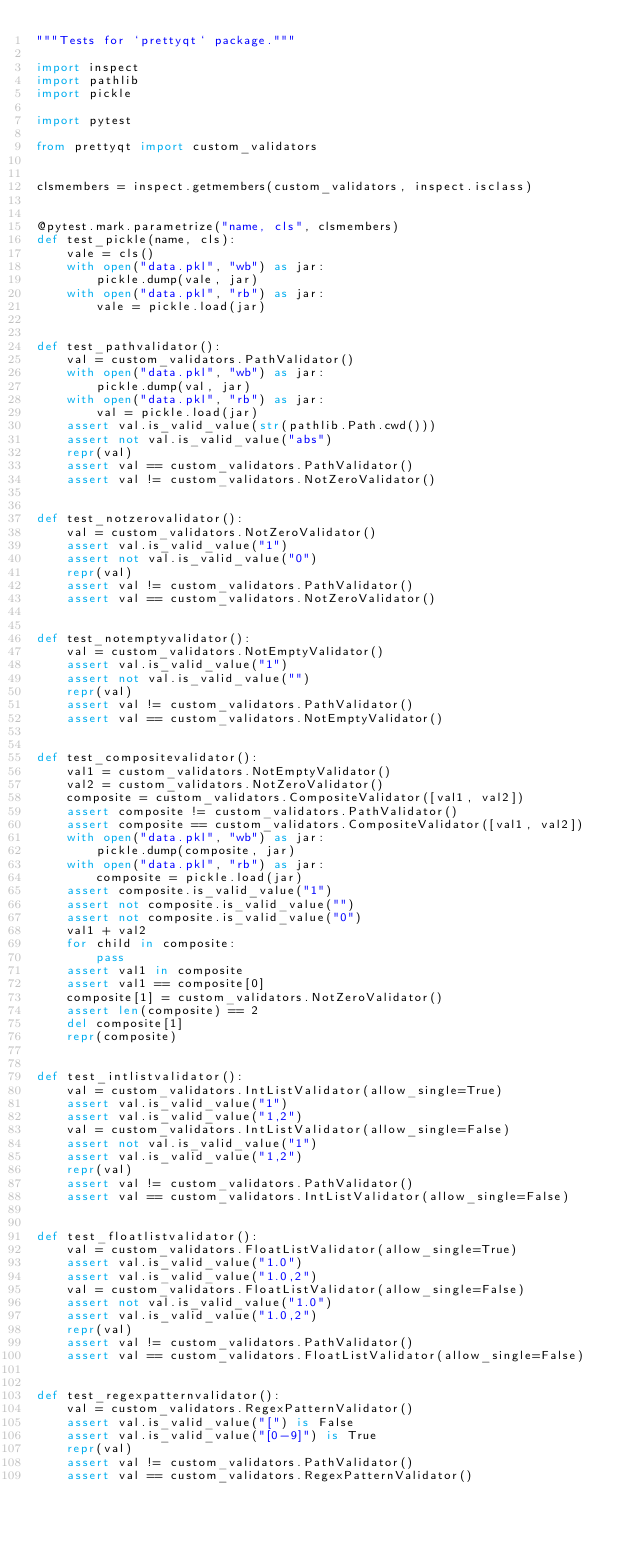<code> <loc_0><loc_0><loc_500><loc_500><_Python_>"""Tests for `prettyqt` package."""

import inspect
import pathlib
import pickle

import pytest

from prettyqt import custom_validators


clsmembers = inspect.getmembers(custom_validators, inspect.isclass)


@pytest.mark.parametrize("name, cls", clsmembers)
def test_pickle(name, cls):
    vale = cls()
    with open("data.pkl", "wb") as jar:
        pickle.dump(vale, jar)
    with open("data.pkl", "rb") as jar:
        vale = pickle.load(jar)


def test_pathvalidator():
    val = custom_validators.PathValidator()
    with open("data.pkl", "wb") as jar:
        pickle.dump(val, jar)
    with open("data.pkl", "rb") as jar:
        val = pickle.load(jar)
    assert val.is_valid_value(str(pathlib.Path.cwd()))
    assert not val.is_valid_value("abs")
    repr(val)
    assert val == custom_validators.PathValidator()
    assert val != custom_validators.NotZeroValidator()


def test_notzerovalidator():
    val = custom_validators.NotZeroValidator()
    assert val.is_valid_value("1")
    assert not val.is_valid_value("0")
    repr(val)
    assert val != custom_validators.PathValidator()
    assert val == custom_validators.NotZeroValidator()


def test_notemptyvalidator():
    val = custom_validators.NotEmptyValidator()
    assert val.is_valid_value("1")
    assert not val.is_valid_value("")
    repr(val)
    assert val != custom_validators.PathValidator()
    assert val == custom_validators.NotEmptyValidator()


def test_compositevalidator():
    val1 = custom_validators.NotEmptyValidator()
    val2 = custom_validators.NotZeroValidator()
    composite = custom_validators.CompositeValidator([val1, val2])
    assert composite != custom_validators.PathValidator()
    assert composite == custom_validators.CompositeValidator([val1, val2])
    with open("data.pkl", "wb") as jar:
        pickle.dump(composite, jar)
    with open("data.pkl", "rb") as jar:
        composite = pickle.load(jar)
    assert composite.is_valid_value("1")
    assert not composite.is_valid_value("")
    assert not composite.is_valid_value("0")
    val1 + val2
    for child in composite:
        pass
    assert val1 in composite
    assert val1 == composite[0]
    composite[1] = custom_validators.NotZeroValidator()
    assert len(composite) == 2
    del composite[1]
    repr(composite)


def test_intlistvalidator():
    val = custom_validators.IntListValidator(allow_single=True)
    assert val.is_valid_value("1")
    assert val.is_valid_value("1,2")
    val = custom_validators.IntListValidator(allow_single=False)
    assert not val.is_valid_value("1")
    assert val.is_valid_value("1,2")
    repr(val)
    assert val != custom_validators.PathValidator()
    assert val == custom_validators.IntListValidator(allow_single=False)


def test_floatlistvalidator():
    val = custom_validators.FloatListValidator(allow_single=True)
    assert val.is_valid_value("1.0")
    assert val.is_valid_value("1.0,2")
    val = custom_validators.FloatListValidator(allow_single=False)
    assert not val.is_valid_value("1.0")
    assert val.is_valid_value("1.0,2")
    repr(val)
    assert val != custom_validators.PathValidator()
    assert val == custom_validators.FloatListValidator(allow_single=False)


def test_regexpatternvalidator():
    val = custom_validators.RegexPatternValidator()
    assert val.is_valid_value("[") is False
    assert val.is_valid_value("[0-9]") is True
    repr(val)
    assert val != custom_validators.PathValidator()
    assert val == custom_validators.RegexPatternValidator()
</code> 